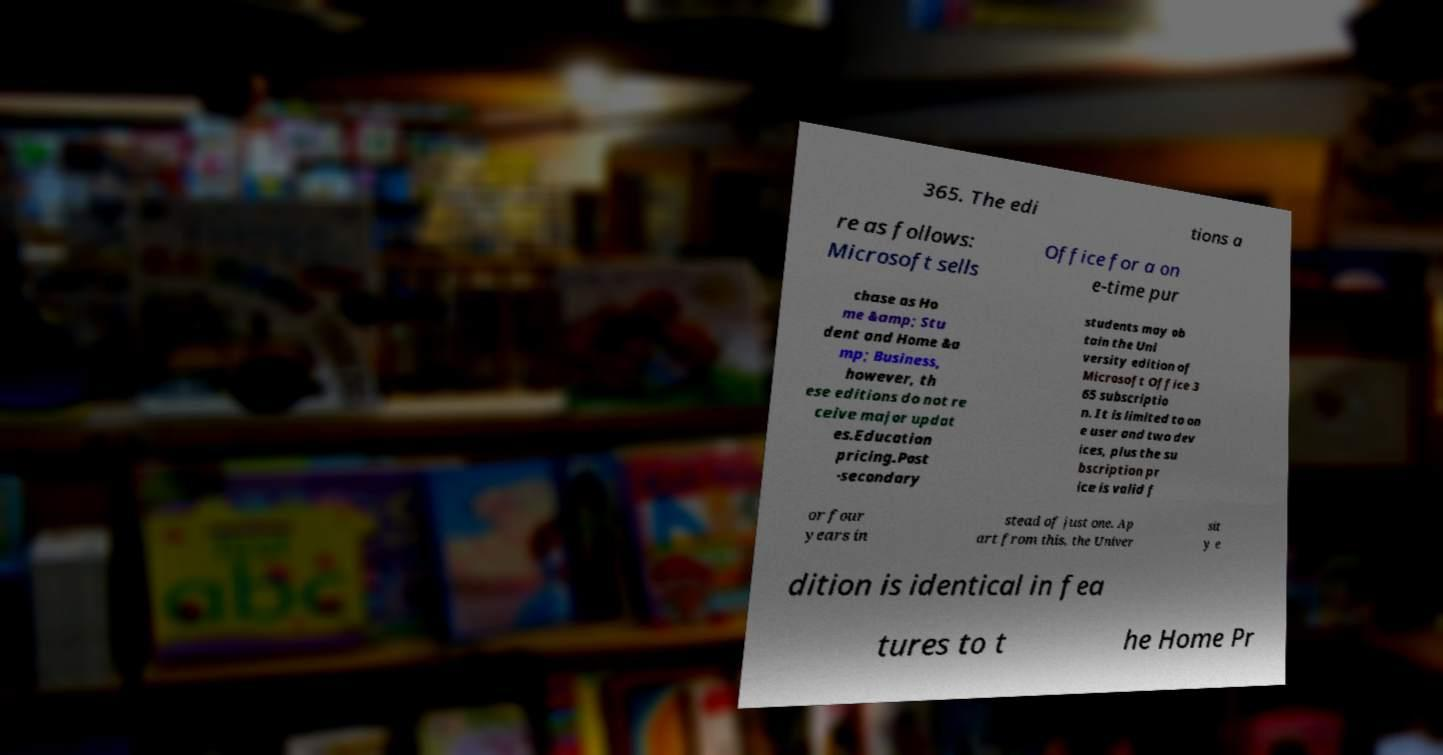Please read and relay the text visible in this image. What does it say? 365. The edi tions a re as follows: Microsoft sells Office for a on e-time pur chase as Ho me &amp; Stu dent and Home &a mp; Business, however, th ese editions do not re ceive major updat es.Education pricing.Post -secondary students may ob tain the Uni versity edition of Microsoft Office 3 65 subscriptio n. It is limited to on e user and two dev ices, plus the su bscription pr ice is valid f or four years in stead of just one. Ap art from this, the Univer sit y e dition is identical in fea tures to t he Home Pr 